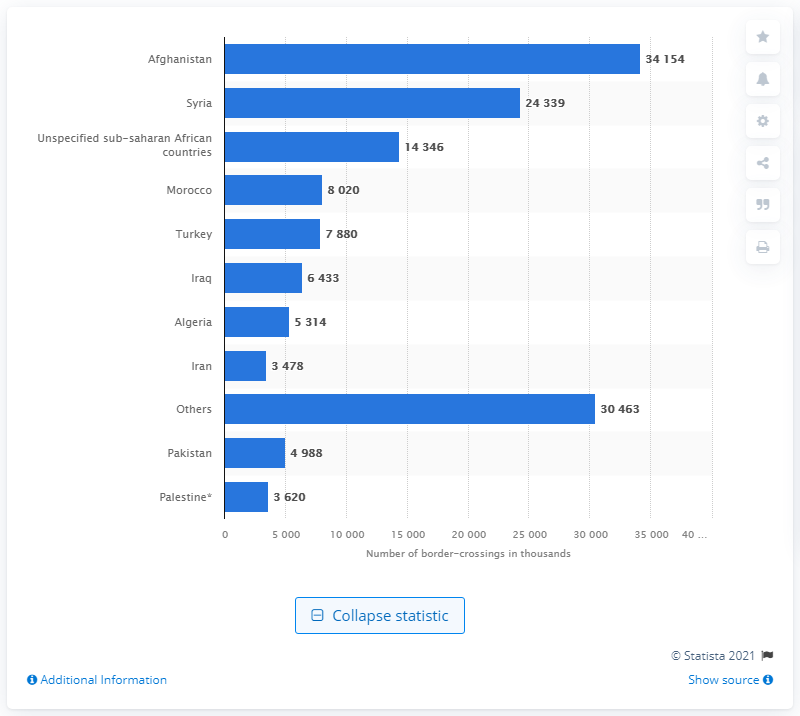Identify some key points in this picture. In 2019, a total of 34,154 individuals from Afghanistan were detected illegally crossing sea borders to reach the EU. 